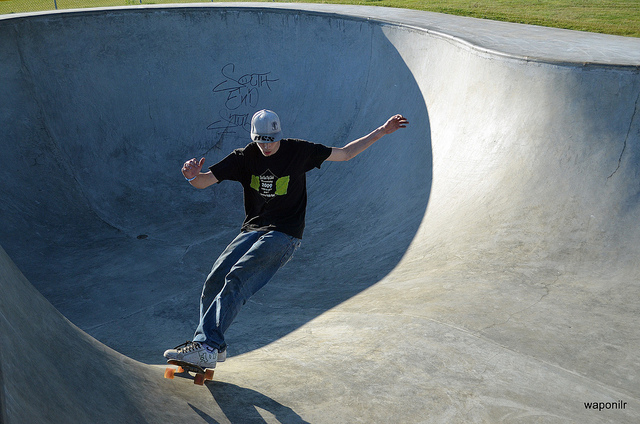<image>What is the logo on the person's tee shirt? I don't know what the logo on the person's tee shirt is. It is not clearly visible. What is the logo on the person's tee shirt? I don't know what the logo on the person's tee shirt is. It can be any of the mentioned options. 